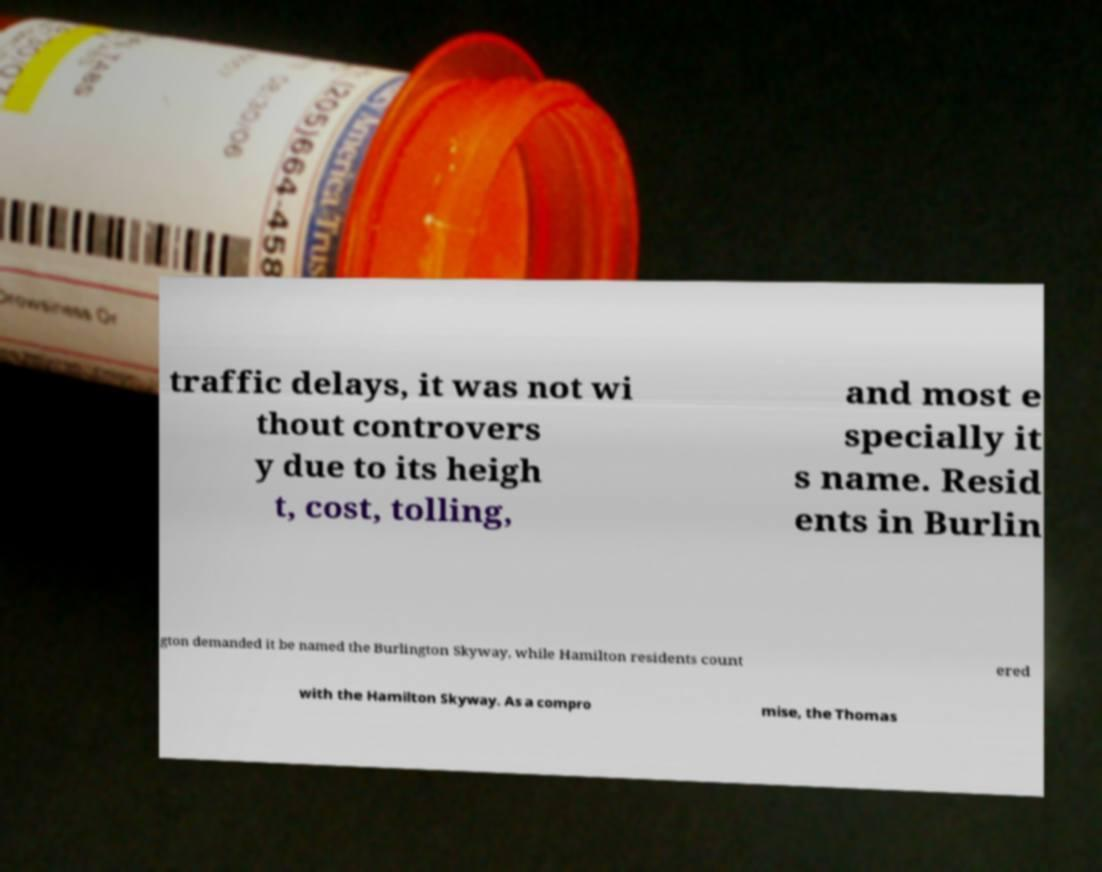Could you extract and type out the text from this image? traffic delays, it was not wi thout controvers y due to its heigh t, cost, tolling, and most e specially it s name. Resid ents in Burlin gton demanded it be named the Burlington Skyway, while Hamilton residents count ered with the Hamilton Skyway. As a compro mise, the Thomas 